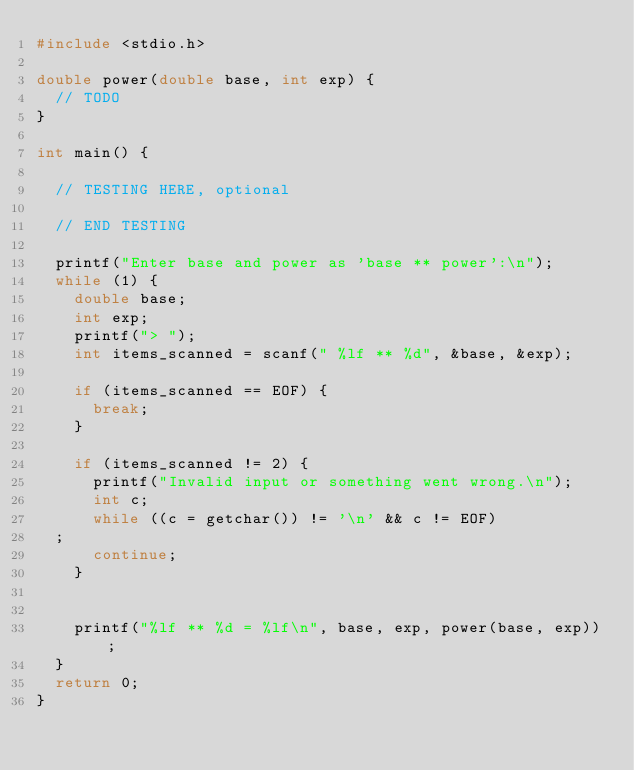Convert code to text. <code><loc_0><loc_0><loc_500><loc_500><_C_>#include <stdio.h>

double power(double base, int exp) {
  // TODO
}

int main() {
  
  // TESTING HERE, optional

  // END TESTING
  
  printf("Enter base and power as 'base ** power':\n");
  while (1) {
    double base;
    int exp;
    printf("> ");
    int items_scanned = scanf(" %lf ** %d", &base, &exp);

    if (items_scanned == EOF) {
      break;
    }

    if (items_scanned != 2) {
      printf("Invalid input or something went wrong.\n");
      int c;
      while ((c = getchar()) != '\n' && c != EOF)
	;
      continue;
    }


    printf("%lf ** %d = %lf\n", base, exp, power(base, exp));
  }
  return 0;
}
</code> 